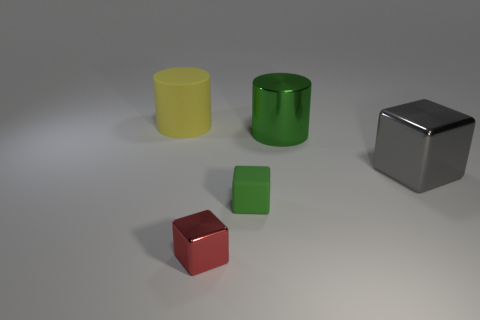What number of spheres are either tiny brown metal objects or small rubber things?
Your response must be concise. 0. What is the color of the large cube?
Offer a very short reply. Gray. Are there more yellow things than green rubber balls?
Your response must be concise. Yes. How many objects are either large shiny things in front of the big metallic cylinder or small green objects?
Your answer should be compact. 2. Does the large block have the same material as the red object?
Offer a terse response. Yes. There is a red metallic thing that is the same shape as the gray object; what size is it?
Offer a very short reply. Small. Does the metallic object in front of the small green block have the same shape as the matte object in front of the large matte cylinder?
Make the answer very short. Yes. There is a gray metal cube; is its size the same as the shiny object left of the green rubber thing?
Make the answer very short. No. What number of other objects are the same material as the small green cube?
Keep it short and to the point. 1. What color is the rubber object behind the green thing that is behind the block behind the tiny green rubber object?
Provide a succinct answer. Yellow. 